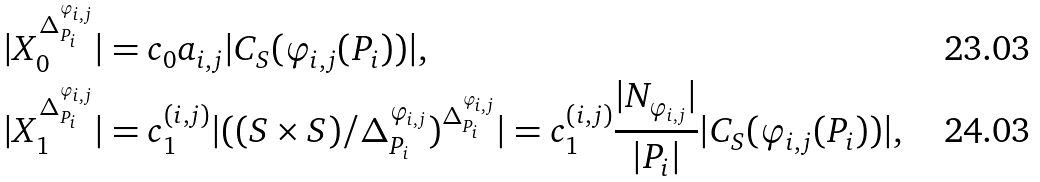Convert formula to latex. <formula><loc_0><loc_0><loc_500><loc_500>| X _ { 0 } ^ { \Delta _ { P _ { i } } ^ { \varphi _ { i , j } } } | & = c _ { 0 } a _ { i , j } | C _ { S } ( \varphi _ { i , j } ( P _ { i } ) ) | , \\ | X _ { 1 } ^ { \Delta _ { P _ { i } } ^ { \varphi _ { i , j } } } | & = c _ { 1 } ^ { ( i , j ) } | ( ( S \times S ) / \Delta _ { P _ { i } } ^ { \varphi _ { i , j } } ) ^ { \Delta _ { P _ { i } } ^ { \varphi _ { i , j } } } | = c _ { 1 } ^ { ( i , j ) } \frac { | N _ { \varphi _ { i , j } } | } { | P _ { i } | } | C _ { S } ( \varphi _ { i , j } ( P _ { i } ) ) | ,</formula> 